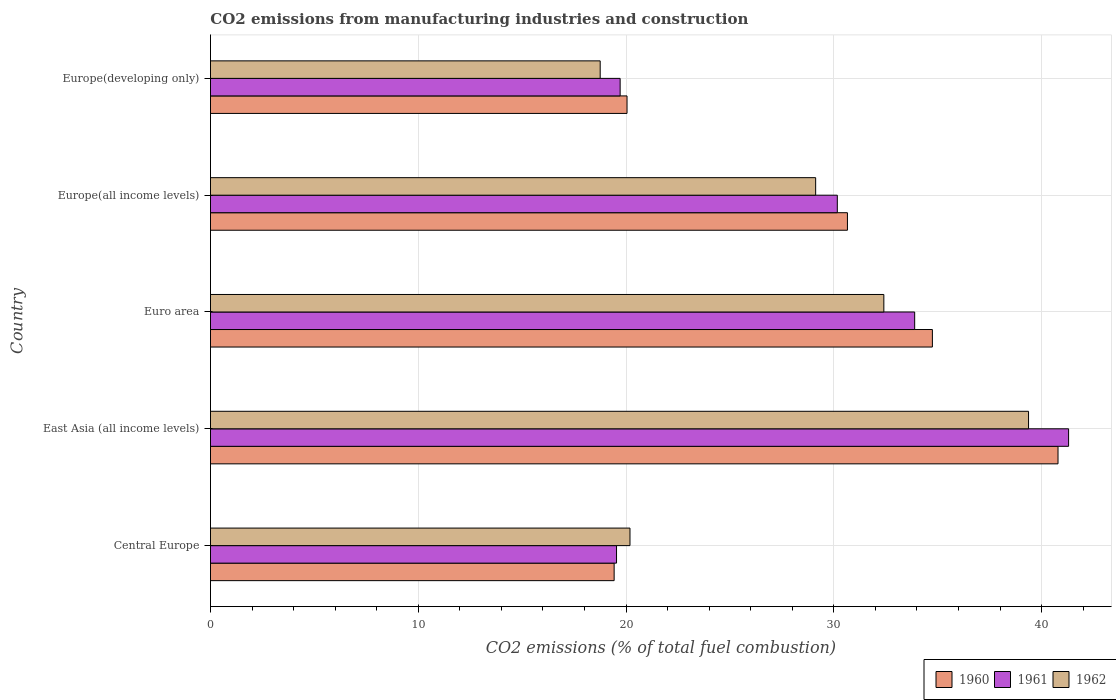How many different coloured bars are there?
Give a very brief answer. 3. How many groups of bars are there?
Ensure brevity in your answer.  5. Are the number of bars on each tick of the Y-axis equal?
Your answer should be very brief. Yes. How many bars are there on the 4th tick from the bottom?
Offer a very short reply. 3. What is the label of the 4th group of bars from the top?
Your answer should be compact. East Asia (all income levels). In how many cases, is the number of bars for a given country not equal to the number of legend labels?
Offer a terse response. 0. What is the amount of CO2 emitted in 1960 in Europe(developing only)?
Your response must be concise. 20.05. Across all countries, what is the maximum amount of CO2 emitted in 1961?
Offer a very short reply. 41.3. Across all countries, what is the minimum amount of CO2 emitted in 1962?
Your answer should be very brief. 18.76. In which country was the amount of CO2 emitted in 1962 maximum?
Make the answer very short. East Asia (all income levels). In which country was the amount of CO2 emitted in 1962 minimum?
Your answer should be compact. Europe(developing only). What is the total amount of CO2 emitted in 1961 in the graph?
Keep it short and to the point. 144.62. What is the difference between the amount of CO2 emitted in 1962 in Central Europe and that in Europe(developing only)?
Give a very brief answer. 1.43. What is the difference between the amount of CO2 emitted in 1960 in Europe(developing only) and the amount of CO2 emitted in 1962 in Central Europe?
Ensure brevity in your answer.  -0.14. What is the average amount of CO2 emitted in 1960 per country?
Keep it short and to the point. 29.13. What is the difference between the amount of CO2 emitted in 1961 and amount of CO2 emitted in 1960 in East Asia (all income levels)?
Your answer should be very brief. 0.51. What is the ratio of the amount of CO2 emitted in 1961 in Central Europe to that in Europe(all income levels)?
Keep it short and to the point. 0.65. Is the amount of CO2 emitted in 1962 in Central Europe less than that in Euro area?
Your answer should be very brief. Yes. Is the difference between the amount of CO2 emitted in 1961 in Central Europe and Europe(developing only) greater than the difference between the amount of CO2 emitted in 1960 in Central Europe and Europe(developing only)?
Offer a terse response. Yes. What is the difference between the highest and the second highest amount of CO2 emitted in 1960?
Keep it short and to the point. 6.05. What is the difference between the highest and the lowest amount of CO2 emitted in 1960?
Your answer should be compact. 21.36. Is the sum of the amount of CO2 emitted in 1962 in Central Europe and Europe(all income levels) greater than the maximum amount of CO2 emitted in 1961 across all countries?
Provide a short and direct response. Yes. Is it the case that in every country, the sum of the amount of CO2 emitted in 1960 and amount of CO2 emitted in 1961 is greater than the amount of CO2 emitted in 1962?
Provide a succinct answer. Yes. Are all the bars in the graph horizontal?
Give a very brief answer. Yes. Are the values on the major ticks of X-axis written in scientific E-notation?
Provide a short and direct response. No. Does the graph contain grids?
Give a very brief answer. Yes. How many legend labels are there?
Provide a succinct answer. 3. How are the legend labels stacked?
Your answer should be very brief. Horizontal. What is the title of the graph?
Your response must be concise. CO2 emissions from manufacturing industries and construction. Does "1989" appear as one of the legend labels in the graph?
Your response must be concise. No. What is the label or title of the X-axis?
Your answer should be very brief. CO2 emissions (% of total fuel combustion). What is the CO2 emissions (% of total fuel combustion) of 1960 in Central Europe?
Make the answer very short. 19.43. What is the CO2 emissions (% of total fuel combustion) in 1961 in Central Europe?
Ensure brevity in your answer.  19.54. What is the CO2 emissions (% of total fuel combustion) of 1962 in Central Europe?
Your answer should be compact. 20.19. What is the CO2 emissions (% of total fuel combustion) in 1960 in East Asia (all income levels)?
Make the answer very short. 40.79. What is the CO2 emissions (% of total fuel combustion) in 1961 in East Asia (all income levels)?
Offer a terse response. 41.3. What is the CO2 emissions (% of total fuel combustion) in 1962 in East Asia (all income levels)?
Offer a very short reply. 39.37. What is the CO2 emissions (% of total fuel combustion) of 1960 in Euro area?
Your response must be concise. 34.75. What is the CO2 emissions (% of total fuel combustion) in 1961 in Euro area?
Provide a short and direct response. 33.89. What is the CO2 emissions (% of total fuel combustion) in 1962 in Euro area?
Keep it short and to the point. 32.41. What is the CO2 emissions (% of total fuel combustion) of 1960 in Europe(all income levels)?
Offer a very short reply. 30.66. What is the CO2 emissions (% of total fuel combustion) in 1961 in Europe(all income levels)?
Make the answer very short. 30.17. What is the CO2 emissions (% of total fuel combustion) in 1962 in Europe(all income levels)?
Provide a short and direct response. 29.13. What is the CO2 emissions (% of total fuel combustion) of 1960 in Europe(developing only)?
Your response must be concise. 20.05. What is the CO2 emissions (% of total fuel combustion) of 1961 in Europe(developing only)?
Provide a short and direct response. 19.72. What is the CO2 emissions (% of total fuel combustion) in 1962 in Europe(developing only)?
Offer a terse response. 18.76. Across all countries, what is the maximum CO2 emissions (% of total fuel combustion) of 1960?
Offer a terse response. 40.79. Across all countries, what is the maximum CO2 emissions (% of total fuel combustion) of 1961?
Give a very brief answer. 41.3. Across all countries, what is the maximum CO2 emissions (% of total fuel combustion) of 1962?
Your answer should be very brief. 39.37. Across all countries, what is the minimum CO2 emissions (% of total fuel combustion) of 1960?
Offer a terse response. 19.43. Across all countries, what is the minimum CO2 emissions (% of total fuel combustion) in 1961?
Your response must be concise. 19.54. Across all countries, what is the minimum CO2 emissions (% of total fuel combustion) in 1962?
Your response must be concise. 18.76. What is the total CO2 emissions (% of total fuel combustion) in 1960 in the graph?
Offer a terse response. 145.67. What is the total CO2 emissions (% of total fuel combustion) in 1961 in the graph?
Provide a short and direct response. 144.62. What is the total CO2 emissions (% of total fuel combustion) of 1962 in the graph?
Provide a short and direct response. 139.86. What is the difference between the CO2 emissions (% of total fuel combustion) of 1960 in Central Europe and that in East Asia (all income levels)?
Your answer should be compact. -21.36. What is the difference between the CO2 emissions (% of total fuel combustion) of 1961 in Central Europe and that in East Asia (all income levels)?
Provide a short and direct response. -21.76. What is the difference between the CO2 emissions (% of total fuel combustion) of 1962 in Central Europe and that in East Asia (all income levels)?
Your answer should be very brief. -19.18. What is the difference between the CO2 emissions (% of total fuel combustion) in 1960 in Central Europe and that in Euro area?
Offer a very short reply. -15.32. What is the difference between the CO2 emissions (% of total fuel combustion) of 1961 in Central Europe and that in Euro area?
Your answer should be very brief. -14.35. What is the difference between the CO2 emissions (% of total fuel combustion) in 1962 in Central Europe and that in Euro area?
Provide a short and direct response. -12.22. What is the difference between the CO2 emissions (% of total fuel combustion) of 1960 in Central Europe and that in Europe(all income levels)?
Your answer should be very brief. -11.23. What is the difference between the CO2 emissions (% of total fuel combustion) of 1961 in Central Europe and that in Europe(all income levels)?
Your answer should be compact. -10.63. What is the difference between the CO2 emissions (% of total fuel combustion) of 1962 in Central Europe and that in Europe(all income levels)?
Offer a very short reply. -8.94. What is the difference between the CO2 emissions (% of total fuel combustion) of 1960 in Central Europe and that in Europe(developing only)?
Provide a short and direct response. -0.62. What is the difference between the CO2 emissions (% of total fuel combustion) of 1961 in Central Europe and that in Europe(developing only)?
Your answer should be compact. -0.17. What is the difference between the CO2 emissions (% of total fuel combustion) in 1962 in Central Europe and that in Europe(developing only)?
Make the answer very short. 1.43. What is the difference between the CO2 emissions (% of total fuel combustion) of 1960 in East Asia (all income levels) and that in Euro area?
Keep it short and to the point. 6.05. What is the difference between the CO2 emissions (% of total fuel combustion) in 1961 in East Asia (all income levels) and that in Euro area?
Your response must be concise. 7.41. What is the difference between the CO2 emissions (% of total fuel combustion) of 1962 in East Asia (all income levels) and that in Euro area?
Keep it short and to the point. 6.96. What is the difference between the CO2 emissions (% of total fuel combustion) in 1960 in East Asia (all income levels) and that in Europe(all income levels)?
Ensure brevity in your answer.  10.13. What is the difference between the CO2 emissions (% of total fuel combustion) in 1961 in East Asia (all income levels) and that in Europe(all income levels)?
Your answer should be very brief. 11.13. What is the difference between the CO2 emissions (% of total fuel combustion) in 1962 in East Asia (all income levels) and that in Europe(all income levels)?
Provide a short and direct response. 10.25. What is the difference between the CO2 emissions (% of total fuel combustion) of 1960 in East Asia (all income levels) and that in Europe(developing only)?
Your response must be concise. 20.74. What is the difference between the CO2 emissions (% of total fuel combustion) of 1961 in East Asia (all income levels) and that in Europe(developing only)?
Give a very brief answer. 21.58. What is the difference between the CO2 emissions (% of total fuel combustion) of 1962 in East Asia (all income levels) and that in Europe(developing only)?
Make the answer very short. 20.62. What is the difference between the CO2 emissions (% of total fuel combustion) of 1960 in Euro area and that in Europe(all income levels)?
Provide a succinct answer. 4.09. What is the difference between the CO2 emissions (% of total fuel combustion) of 1961 in Euro area and that in Europe(all income levels)?
Your answer should be compact. 3.72. What is the difference between the CO2 emissions (% of total fuel combustion) in 1962 in Euro area and that in Europe(all income levels)?
Keep it short and to the point. 3.28. What is the difference between the CO2 emissions (% of total fuel combustion) in 1960 in Euro area and that in Europe(developing only)?
Offer a terse response. 14.7. What is the difference between the CO2 emissions (% of total fuel combustion) of 1961 in Euro area and that in Europe(developing only)?
Make the answer very short. 14.18. What is the difference between the CO2 emissions (% of total fuel combustion) in 1962 in Euro area and that in Europe(developing only)?
Ensure brevity in your answer.  13.65. What is the difference between the CO2 emissions (% of total fuel combustion) in 1960 in Europe(all income levels) and that in Europe(developing only)?
Your answer should be compact. 10.61. What is the difference between the CO2 emissions (% of total fuel combustion) in 1961 in Europe(all income levels) and that in Europe(developing only)?
Make the answer very short. 10.45. What is the difference between the CO2 emissions (% of total fuel combustion) in 1962 in Europe(all income levels) and that in Europe(developing only)?
Give a very brief answer. 10.37. What is the difference between the CO2 emissions (% of total fuel combustion) of 1960 in Central Europe and the CO2 emissions (% of total fuel combustion) of 1961 in East Asia (all income levels)?
Your answer should be very brief. -21.87. What is the difference between the CO2 emissions (% of total fuel combustion) in 1960 in Central Europe and the CO2 emissions (% of total fuel combustion) in 1962 in East Asia (all income levels)?
Offer a terse response. -19.94. What is the difference between the CO2 emissions (% of total fuel combustion) of 1961 in Central Europe and the CO2 emissions (% of total fuel combustion) of 1962 in East Asia (all income levels)?
Your response must be concise. -19.83. What is the difference between the CO2 emissions (% of total fuel combustion) of 1960 in Central Europe and the CO2 emissions (% of total fuel combustion) of 1961 in Euro area?
Give a very brief answer. -14.46. What is the difference between the CO2 emissions (% of total fuel combustion) in 1960 in Central Europe and the CO2 emissions (% of total fuel combustion) in 1962 in Euro area?
Provide a succinct answer. -12.98. What is the difference between the CO2 emissions (% of total fuel combustion) in 1961 in Central Europe and the CO2 emissions (% of total fuel combustion) in 1962 in Euro area?
Ensure brevity in your answer.  -12.87. What is the difference between the CO2 emissions (% of total fuel combustion) of 1960 in Central Europe and the CO2 emissions (% of total fuel combustion) of 1961 in Europe(all income levels)?
Provide a succinct answer. -10.74. What is the difference between the CO2 emissions (% of total fuel combustion) in 1960 in Central Europe and the CO2 emissions (% of total fuel combustion) in 1962 in Europe(all income levels)?
Give a very brief answer. -9.7. What is the difference between the CO2 emissions (% of total fuel combustion) of 1961 in Central Europe and the CO2 emissions (% of total fuel combustion) of 1962 in Europe(all income levels)?
Make the answer very short. -9.58. What is the difference between the CO2 emissions (% of total fuel combustion) in 1960 in Central Europe and the CO2 emissions (% of total fuel combustion) in 1961 in Europe(developing only)?
Your response must be concise. -0.29. What is the difference between the CO2 emissions (% of total fuel combustion) of 1960 in Central Europe and the CO2 emissions (% of total fuel combustion) of 1962 in Europe(developing only)?
Keep it short and to the point. 0.67. What is the difference between the CO2 emissions (% of total fuel combustion) of 1961 in Central Europe and the CO2 emissions (% of total fuel combustion) of 1962 in Europe(developing only)?
Your response must be concise. 0.79. What is the difference between the CO2 emissions (% of total fuel combustion) in 1960 in East Asia (all income levels) and the CO2 emissions (% of total fuel combustion) in 1961 in Euro area?
Your answer should be very brief. 6.9. What is the difference between the CO2 emissions (% of total fuel combustion) in 1960 in East Asia (all income levels) and the CO2 emissions (% of total fuel combustion) in 1962 in Euro area?
Keep it short and to the point. 8.38. What is the difference between the CO2 emissions (% of total fuel combustion) of 1961 in East Asia (all income levels) and the CO2 emissions (% of total fuel combustion) of 1962 in Euro area?
Provide a short and direct response. 8.89. What is the difference between the CO2 emissions (% of total fuel combustion) of 1960 in East Asia (all income levels) and the CO2 emissions (% of total fuel combustion) of 1961 in Europe(all income levels)?
Your answer should be very brief. 10.62. What is the difference between the CO2 emissions (% of total fuel combustion) in 1960 in East Asia (all income levels) and the CO2 emissions (% of total fuel combustion) in 1962 in Europe(all income levels)?
Provide a succinct answer. 11.66. What is the difference between the CO2 emissions (% of total fuel combustion) of 1961 in East Asia (all income levels) and the CO2 emissions (% of total fuel combustion) of 1962 in Europe(all income levels)?
Keep it short and to the point. 12.17. What is the difference between the CO2 emissions (% of total fuel combustion) of 1960 in East Asia (all income levels) and the CO2 emissions (% of total fuel combustion) of 1961 in Europe(developing only)?
Your answer should be compact. 21.07. What is the difference between the CO2 emissions (% of total fuel combustion) in 1960 in East Asia (all income levels) and the CO2 emissions (% of total fuel combustion) in 1962 in Europe(developing only)?
Give a very brief answer. 22.03. What is the difference between the CO2 emissions (% of total fuel combustion) in 1961 in East Asia (all income levels) and the CO2 emissions (% of total fuel combustion) in 1962 in Europe(developing only)?
Offer a very short reply. 22.54. What is the difference between the CO2 emissions (% of total fuel combustion) in 1960 in Euro area and the CO2 emissions (% of total fuel combustion) in 1961 in Europe(all income levels)?
Your answer should be compact. 4.58. What is the difference between the CO2 emissions (% of total fuel combustion) of 1960 in Euro area and the CO2 emissions (% of total fuel combustion) of 1962 in Europe(all income levels)?
Offer a terse response. 5.62. What is the difference between the CO2 emissions (% of total fuel combustion) in 1961 in Euro area and the CO2 emissions (% of total fuel combustion) in 1962 in Europe(all income levels)?
Ensure brevity in your answer.  4.77. What is the difference between the CO2 emissions (% of total fuel combustion) in 1960 in Euro area and the CO2 emissions (% of total fuel combustion) in 1961 in Europe(developing only)?
Provide a short and direct response. 15.03. What is the difference between the CO2 emissions (% of total fuel combustion) in 1960 in Euro area and the CO2 emissions (% of total fuel combustion) in 1962 in Europe(developing only)?
Keep it short and to the point. 15.99. What is the difference between the CO2 emissions (% of total fuel combustion) of 1961 in Euro area and the CO2 emissions (% of total fuel combustion) of 1962 in Europe(developing only)?
Make the answer very short. 15.14. What is the difference between the CO2 emissions (% of total fuel combustion) of 1960 in Europe(all income levels) and the CO2 emissions (% of total fuel combustion) of 1961 in Europe(developing only)?
Make the answer very short. 10.94. What is the difference between the CO2 emissions (% of total fuel combustion) of 1960 in Europe(all income levels) and the CO2 emissions (% of total fuel combustion) of 1962 in Europe(developing only)?
Give a very brief answer. 11.9. What is the difference between the CO2 emissions (% of total fuel combustion) of 1961 in Europe(all income levels) and the CO2 emissions (% of total fuel combustion) of 1962 in Europe(developing only)?
Your response must be concise. 11.41. What is the average CO2 emissions (% of total fuel combustion) of 1960 per country?
Make the answer very short. 29.13. What is the average CO2 emissions (% of total fuel combustion) of 1961 per country?
Your answer should be compact. 28.92. What is the average CO2 emissions (% of total fuel combustion) in 1962 per country?
Keep it short and to the point. 27.97. What is the difference between the CO2 emissions (% of total fuel combustion) of 1960 and CO2 emissions (% of total fuel combustion) of 1961 in Central Europe?
Provide a short and direct response. -0.11. What is the difference between the CO2 emissions (% of total fuel combustion) in 1960 and CO2 emissions (% of total fuel combustion) in 1962 in Central Europe?
Offer a very short reply. -0.76. What is the difference between the CO2 emissions (% of total fuel combustion) of 1961 and CO2 emissions (% of total fuel combustion) of 1962 in Central Europe?
Your response must be concise. -0.65. What is the difference between the CO2 emissions (% of total fuel combustion) of 1960 and CO2 emissions (% of total fuel combustion) of 1961 in East Asia (all income levels)?
Your answer should be compact. -0.51. What is the difference between the CO2 emissions (% of total fuel combustion) of 1960 and CO2 emissions (% of total fuel combustion) of 1962 in East Asia (all income levels)?
Give a very brief answer. 1.42. What is the difference between the CO2 emissions (% of total fuel combustion) of 1961 and CO2 emissions (% of total fuel combustion) of 1962 in East Asia (all income levels)?
Your response must be concise. 1.93. What is the difference between the CO2 emissions (% of total fuel combustion) in 1960 and CO2 emissions (% of total fuel combustion) in 1961 in Euro area?
Keep it short and to the point. 0.85. What is the difference between the CO2 emissions (% of total fuel combustion) of 1960 and CO2 emissions (% of total fuel combustion) of 1962 in Euro area?
Your response must be concise. 2.34. What is the difference between the CO2 emissions (% of total fuel combustion) in 1961 and CO2 emissions (% of total fuel combustion) in 1962 in Euro area?
Give a very brief answer. 1.48. What is the difference between the CO2 emissions (% of total fuel combustion) of 1960 and CO2 emissions (% of total fuel combustion) of 1961 in Europe(all income levels)?
Your answer should be very brief. 0.49. What is the difference between the CO2 emissions (% of total fuel combustion) in 1960 and CO2 emissions (% of total fuel combustion) in 1962 in Europe(all income levels)?
Ensure brevity in your answer.  1.53. What is the difference between the CO2 emissions (% of total fuel combustion) of 1961 and CO2 emissions (% of total fuel combustion) of 1962 in Europe(all income levels)?
Ensure brevity in your answer.  1.04. What is the difference between the CO2 emissions (% of total fuel combustion) of 1960 and CO2 emissions (% of total fuel combustion) of 1961 in Europe(developing only)?
Offer a very short reply. 0.33. What is the difference between the CO2 emissions (% of total fuel combustion) of 1960 and CO2 emissions (% of total fuel combustion) of 1962 in Europe(developing only)?
Make the answer very short. 1.29. What is the difference between the CO2 emissions (% of total fuel combustion) in 1961 and CO2 emissions (% of total fuel combustion) in 1962 in Europe(developing only)?
Your answer should be very brief. 0.96. What is the ratio of the CO2 emissions (% of total fuel combustion) in 1960 in Central Europe to that in East Asia (all income levels)?
Offer a terse response. 0.48. What is the ratio of the CO2 emissions (% of total fuel combustion) of 1961 in Central Europe to that in East Asia (all income levels)?
Your response must be concise. 0.47. What is the ratio of the CO2 emissions (% of total fuel combustion) of 1962 in Central Europe to that in East Asia (all income levels)?
Keep it short and to the point. 0.51. What is the ratio of the CO2 emissions (% of total fuel combustion) of 1960 in Central Europe to that in Euro area?
Keep it short and to the point. 0.56. What is the ratio of the CO2 emissions (% of total fuel combustion) of 1961 in Central Europe to that in Euro area?
Offer a very short reply. 0.58. What is the ratio of the CO2 emissions (% of total fuel combustion) in 1962 in Central Europe to that in Euro area?
Your response must be concise. 0.62. What is the ratio of the CO2 emissions (% of total fuel combustion) of 1960 in Central Europe to that in Europe(all income levels)?
Your answer should be compact. 0.63. What is the ratio of the CO2 emissions (% of total fuel combustion) in 1961 in Central Europe to that in Europe(all income levels)?
Ensure brevity in your answer.  0.65. What is the ratio of the CO2 emissions (% of total fuel combustion) in 1962 in Central Europe to that in Europe(all income levels)?
Provide a short and direct response. 0.69. What is the ratio of the CO2 emissions (% of total fuel combustion) of 1960 in Central Europe to that in Europe(developing only)?
Your answer should be compact. 0.97. What is the ratio of the CO2 emissions (% of total fuel combustion) in 1961 in Central Europe to that in Europe(developing only)?
Give a very brief answer. 0.99. What is the ratio of the CO2 emissions (% of total fuel combustion) of 1962 in Central Europe to that in Europe(developing only)?
Offer a very short reply. 1.08. What is the ratio of the CO2 emissions (% of total fuel combustion) in 1960 in East Asia (all income levels) to that in Euro area?
Offer a very short reply. 1.17. What is the ratio of the CO2 emissions (% of total fuel combustion) of 1961 in East Asia (all income levels) to that in Euro area?
Keep it short and to the point. 1.22. What is the ratio of the CO2 emissions (% of total fuel combustion) in 1962 in East Asia (all income levels) to that in Euro area?
Provide a succinct answer. 1.21. What is the ratio of the CO2 emissions (% of total fuel combustion) in 1960 in East Asia (all income levels) to that in Europe(all income levels)?
Give a very brief answer. 1.33. What is the ratio of the CO2 emissions (% of total fuel combustion) in 1961 in East Asia (all income levels) to that in Europe(all income levels)?
Provide a succinct answer. 1.37. What is the ratio of the CO2 emissions (% of total fuel combustion) of 1962 in East Asia (all income levels) to that in Europe(all income levels)?
Your response must be concise. 1.35. What is the ratio of the CO2 emissions (% of total fuel combustion) of 1960 in East Asia (all income levels) to that in Europe(developing only)?
Ensure brevity in your answer.  2.03. What is the ratio of the CO2 emissions (% of total fuel combustion) of 1961 in East Asia (all income levels) to that in Europe(developing only)?
Keep it short and to the point. 2.09. What is the ratio of the CO2 emissions (% of total fuel combustion) in 1962 in East Asia (all income levels) to that in Europe(developing only)?
Provide a short and direct response. 2.1. What is the ratio of the CO2 emissions (% of total fuel combustion) of 1960 in Euro area to that in Europe(all income levels)?
Keep it short and to the point. 1.13. What is the ratio of the CO2 emissions (% of total fuel combustion) in 1961 in Euro area to that in Europe(all income levels)?
Offer a terse response. 1.12. What is the ratio of the CO2 emissions (% of total fuel combustion) in 1962 in Euro area to that in Europe(all income levels)?
Offer a very short reply. 1.11. What is the ratio of the CO2 emissions (% of total fuel combustion) of 1960 in Euro area to that in Europe(developing only)?
Provide a succinct answer. 1.73. What is the ratio of the CO2 emissions (% of total fuel combustion) in 1961 in Euro area to that in Europe(developing only)?
Provide a succinct answer. 1.72. What is the ratio of the CO2 emissions (% of total fuel combustion) of 1962 in Euro area to that in Europe(developing only)?
Offer a terse response. 1.73. What is the ratio of the CO2 emissions (% of total fuel combustion) of 1960 in Europe(all income levels) to that in Europe(developing only)?
Offer a terse response. 1.53. What is the ratio of the CO2 emissions (% of total fuel combustion) of 1961 in Europe(all income levels) to that in Europe(developing only)?
Provide a short and direct response. 1.53. What is the ratio of the CO2 emissions (% of total fuel combustion) in 1962 in Europe(all income levels) to that in Europe(developing only)?
Make the answer very short. 1.55. What is the difference between the highest and the second highest CO2 emissions (% of total fuel combustion) in 1960?
Your response must be concise. 6.05. What is the difference between the highest and the second highest CO2 emissions (% of total fuel combustion) of 1961?
Provide a succinct answer. 7.41. What is the difference between the highest and the second highest CO2 emissions (% of total fuel combustion) in 1962?
Give a very brief answer. 6.96. What is the difference between the highest and the lowest CO2 emissions (% of total fuel combustion) in 1960?
Your response must be concise. 21.36. What is the difference between the highest and the lowest CO2 emissions (% of total fuel combustion) in 1961?
Keep it short and to the point. 21.76. What is the difference between the highest and the lowest CO2 emissions (% of total fuel combustion) in 1962?
Make the answer very short. 20.62. 